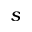<formula> <loc_0><loc_0><loc_500><loc_500>s</formula> 